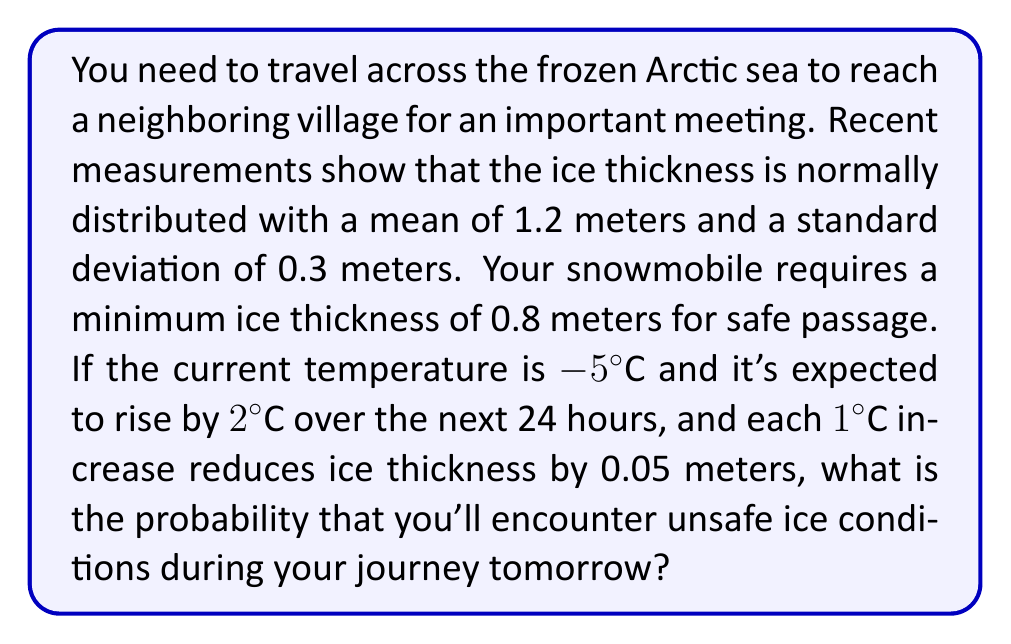Can you solve this math problem? Let's approach this problem step-by-step:

1) First, we need to calculate the expected ice thickness after the temperature increase:
   $$\text{Thickness reduction} = 2°C \times 0.05 \text{ m/°C} = 0.1 \text{ m}$$
   $$\text{New mean thickness} = 1.2 \text{ m} - 0.1 \text{ m} = 1.1 \text{ m}$$

2) The standard deviation remains unchanged at 0.3 meters.

3) We need to find the probability that the ice thickness is less than 0.8 meters. We can use the z-score formula:
   $$z = \frac{x - \mu}{\sigma}$$
   where $x$ is the critical value (0.8 m), $\mu$ is the mean (1.1 m), and $\sigma$ is the standard deviation (0.3 m).

4) Plugging in these values:
   $$z = \frac{0.8 - 1.1}{0.3} = -1$$

5) This z-score of -1 corresponds to the probability that the ice thickness is less than 0.8 meters.

6) Using a standard normal distribution table or calculator, we find that the area to the left of z = -1 is approximately 0.1587.

7) Therefore, the probability of encountering unsafe ice conditions (thickness less than 0.8 meters) is about 0.1587 or 15.87%.
Answer: The probability of encountering unsafe ice conditions during your journey tomorrow is approximately 0.1587 or 15.87%. 